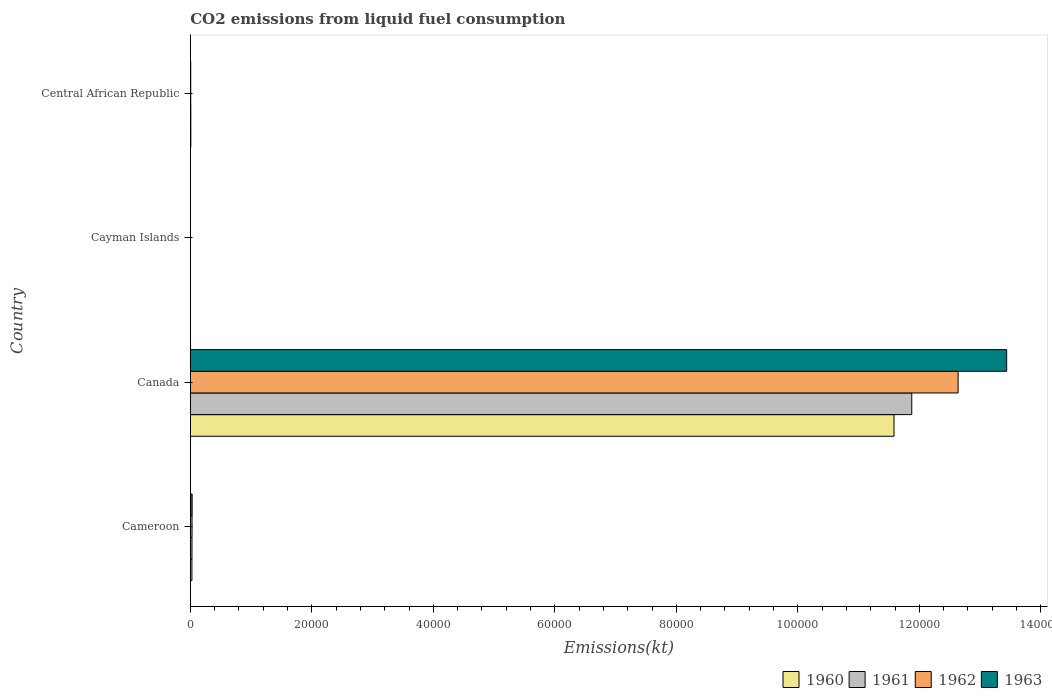How many groups of bars are there?
Your answer should be very brief. 4. Are the number of bars per tick equal to the number of legend labels?
Ensure brevity in your answer.  Yes. Are the number of bars on each tick of the Y-axis equal?
Ensure brevity in your answer.  Yes. How many bars are there on the 2nd tick from the top?
Provide a short and direct response. 4. How many bars are there on the 4th tick from the bottom?
Offer a very short reply. 4. What is the label of the 4th group of bars from the top?
Offer a very short reply. Cameroon. What is the amount of CO2 emitted in 1962 in Central African Republic?
Your answer should be very brief. 73.34. Across all countries, what is the maximum amount of CO2 emitted in 1962?
Ensure brevity in your answer.  1.26e+05. Across all countries, what is the minimum amount of CO2 emitted in 1960?
Provide a short and direct response. 11. In which country was the amount of CO2 emitted in 1961 maximum?
Make the answer very short. Canada. In which country was the amount of CO2 emitted in 1963 minimum?
Give a very brief answer. Cayman Islands. What is the total amount of CO2 emitted in 1960 in the graph?
Your answer should be very brief. 1.16e+05. What is the difference between the amount of CO2 emitted in 1962 in Cameroon and that in Canada?
Provide a succinct answer. -1.26e+05. What is the difference between the amount of CO2 emitted in 1960 in Cameroon and the amount of CO2 emitted in 1962 in Central African Republic?
Provide a succinct answer. 194.35. What is the average amount of CO2 emitted in 1962 per country?
Give a very brief answer. 3.17e+04. What is the difference between the amount of CO2 emitted in 1963 and amount of CO2 emitted in 1962 in Canada?
Keep it short and to the point. 7990.39. In how many countries, is the amount of CO2 emitted in 1962 greater than 64000 kt?
Your answer should be compact. 1. What is the ratio of the amount of CO2 emitted in 1962 in Canada to that in Cayman Islands?
Ensure brevity in your answer.  1.15e+04. Is the amount of CO2 emitted in 1961 in Cayman Islands less than that in Central African Republic?
Ensure brevity in your answer.  Yes. Is the difference between the amount of CO2 emitted in 1963 in Cameroon and Canada greater than the difference between the amount of CO2 emitted in 1962 in Cameroon and Canada?
Ensure brevity in your answer.  No. What is the difference between the highest and the second highest amount of CO2 emitted in 1960?
Provide a short and direct response. 1.16e+05. What is the difference between the highest and the lowest amount of CO2 emitted in 1960?
Your answer should be compact. 1.16e+05. Is the sum of the amount of CO2 emitted in 1962 in Canada and Central African Republic greater than the maximum amount of CO2 emitted in 1963 across all countries?
Your answer should be very brief. No. Is it the case that in every country, the sum of the amount of CO2 emitted in 1960 and amount of CO2 emitted in 1963 is greater than the sum of amount of CO2 emitted in 1962 and amount of CO2 emitted in 1961?
Your response must be concise. No. What does the 3rd bar from the top in Cameroon represents?
Your answer should be compact. 1961. Is it the case that in every country, the sum of the amount of CO2 emitted in 1960 and amount of CO2 emitted in 1963 is greater than the amount of CO2 emitted in 1961?
Offer a very short reply. Yes. Are all the bars in the graph horizontal?
Your answer should be compact. Yes. How many countries are there in the graph?
Provide a succinct answer. 4. What is the difference between two consecutive major ticks on the X-axis?
Offer a very short reply. 2.00e+04. Are the values on the major ticks of X-axis written in scientific E-notation?
Give a very brief answer. No. Does the graph contain grids?
Ensure brevity in your answer.  No. How many legend labels are there?
Your answer should be very brief. 4. What is the title of the graph?
Provide a short and direct response. CO2 emissions from liquid fuel consumption. What is the label or title of the X-axis?
Provide a short and direct response. Emissions(kt). What is the label or title of the Y-axis?
Offer a terse response. Country. What is the Emissions(kt) in 1960 in Cameroon?
Make the answer very short. 267.69. What is the Emissions(kt) of 1961 in Cameroon?
Keep it short and to the point. 278.69. What is the Emissions(kt) of 1962 in Cameroon?
Your answer should be very brief. 289.69. What is the Emissions(kt) in 1963 in Cameroon?
Your answer should be compact. 300.69. What is the Emissions(kt) of 1960 in Canada?
Make the answer very short. 1.16e+05. What is the Emissions(kt) of 1961 in Canada?
Keep it short and to the point. 1.19e+05. What is the Emissions(kt) of 1962 in Canada?
Offer a very short reply. 1.26e+05. What is the Emissions(kt) of 1963 in Canada?
Your response must be concise. 1.34e+05. What is the Emissions(kt) of 1960 in Cayman Islands?
Keep it short and to the point. 11. What is the Emissions(kt) in 1961 in Cayman Islands?
Your answer should be compact. 11. What is the Emissions(kt) in 1962 in Cayman Islands?
Make the answer very short. 11. What is the Emissions(kt) in 1963 in Cayman Islands?
Offer a very short reply. 11. What is the Emissions(kt) in 1960 in Central African Republic?
Ensure brevity in your answer.  88.01. What is the Emissions(kt) in 1961 in Central African Republic?
Keep it short and to the point. 88.01. What is the Emissions(kt) in 1962 in Central African Republic?
Make the answer very short. 73.34. What is the Emissions(kt) in 1963 in Central African Republic?
Offer a terse response. 73.34. Across all countries, what is the maximum Emissions(kt) in 1960?
Make the answer very short. 1.16e+05. Across all countries, what is the maximum Emissions(kt) of 1961?
Offer a terse response. 1.19e+05. Across all countries, what is the maximum Emissions(kt) of 1962?
Provide a succinct answer. 1.26e+05. Across all countries, what is the maximum Emissions(kt) of 1963?
Make the answer very short. 1.34e+05. Across all countries, what is the minimum Emissions(kt) of 1960?
Keep it short and to the point. 11. Across all countries, what is the minimum Emissions(kt) in 1961?
Give a very brief answer. 11. Across all countries, what is the minimum Emissions(kt) of 1962?
Your response must be concise. 11. Across all countries, what is the minimum Emissions(kt) of 1963?
Your answer should be very brief. 11. What is the total Emissions(kt) in 1960 in the graph?
Provide a short and direct response. 1.16e+05. What is the total Emissions(kt) of 1961 in the graph?
Offer a terse response. 1.19e+05. What is the total Emissions(kt) of 1962 in the graph?
Give a very brief answer. 1.27e+05. What is the total Emissions(kt) in 1963 in the graph?
Offer a very short reply. 1.35e+05. What is the difference between the Emissions(kt) of 1960 in Cameroon and that in Canada?
Ensure brevity in your answer.  -1.16e+05. What is the difference between the Emissions(kt) in 1961 in Cameroon and that in Canada?
Your response must be concise. -1.18e+05. What is the difference between the Emissions(kt) of 1962 in Cameroon and that in Canada?
Your answer should be very brief. -1.26e+05. What is the difference between the Emissions(kt) in 1963 in Cameroon and that in Canada?
Provide a short and direct response. -1.34e+05. What is the difference between the Emissions(kt) of 1960 in Cameroon and that in Cayman Islands?
Give a very brief answer. 256.69. What is the difference between the Emissions(kt) in 1961 in Cameroon and that in Cayman Islands?
Ensure brevity in your answer.  267.69. What is the difference between the Emissions(kt) in 1962 in Cameroon and that in Cayman Islands?
Your response must be concise. 278.69. What is the difference between the Emissions(kt) in 1963 in Cameroon and that in Cayman Islands?
Make the answer very short. 289.69. What is the difference between the Emissions(kt) of 1960 in Cameroon and that in Central African Republic?
Offer a very short reply. 179.68. What is the difference between the Emissions(kt) of 1961 in Cameroon and that in Central African Republic?
Offer a terse response. 190.68. What is the difference between the Emissions(kt) of 1962 in Cameroon and that in Central African Republic?
Your response must be concise. 216.35. What is the difference between the Emissions(kt) in 1963 in Cameroon and that in Central African Republic?
Keep it short and to the point. 227.35. What is the difference between the Emissions(kt) in 1960 in Canada and that in Cayman Islands?
Make the answer very short. 1.16e+05. What is the difference between the Emissions(kt) of 1961 in Canada and that in Cayman Islands?
Offer a very short reply. 1.19e+05. What is the difference between the Emissions(kt) in 1962 in Canada and that in Cayman Islands?
Ensure brevity in your answer.  1.26e+05. What is the difference between the Emissions(kt) in 1963 in Canada and that in Cayman Islands?
Keep it short and to the point. 1.34e+05. What is the difference between the Emissions(kt) of 1960 in Canada and that in Central African Republic?
Your response must be concise. 1.16e+05. What is the difference between the Emissions(kt) in 1961 in Canada and that in Central African Republic?
Your answer should be compact. 1.19e+05. What is the difference between the Emissions(kt) in 1962 in Canada and that in Central African Republic?
Your response must be concise. 1.26e+05. What is the difference between the Emissions(kt) of 1963 in Canada and that in Central African Republic?
Offer a terse response. 1.34e+05. What is the difference between the Emissions(kt) in 1960 in Cayman Islands and that in Central African Republic?
Your answer should be compact. -77.01. What is the difference between the Emissions(kt) of 1961 in Cayman Islands and that in Central African Republic?
Your response must be concise. -77.01. What is the difference between the Emissions(kt) in 1962 in Cayman Islands and that in Central African Republic?
Offer a terse response. -62.34. What is the difference between the Emissions(kt) in 1963 in Cayman Islands and that in Central African Republic?
Ensure brevity in your answer.  -62.34. What is the difference between the Emissions(kt) of 1960 in Cameroon and the Emissions(kt) of 1961 in Canada?
Your response must be concise. -1.18e+05. What is the difference between the Emissions(kt) in 1960 in Cameroon and the Emissions(kt) in 1962 in Canada?
Your response must be concise. -1.26e+05. What is the difference between the Emissions(kt) of 1960 in Cameroon and the Emissions(kt) of 1963 in Canada?
Your answer should be very brief. -1.34e+05. What is the difference between the Emissions(kt) of 1961 in Cameroon and the Emissions(kt) of 1962 in Canada?
Make the answer very short. -1.26e+05. What is the difference between the Emissions(kt) in 1961 in Cameroon and the Emissions(kt) in 1963 in Canada?
Offer a very short reply. -1.34e+05. What is the difference between the Emissions(kt) in 1962 in Cameroon and the Emissions(kt) in 1963 in Canada?
Offer a terse response. -1.34e+05. What is the difference between the Emissions(kt) in 1960 in Cameroon and the Emissions(kt) in 1961 in Cayman Islands?
Your answer should be very brief. 256.69. What is the difference between the Emissions(kt) in 1960 in Cameroon and the Emissions(kt) in 1962 in Cayman Islands?
Provide a short and direct response. 256.69. What is the difference between the Emissions(kt) of 1960 in Cameroon and the Emissions(kt) of 1963 in Cayman Islands?
Offer a very short reply. 256.69. What is the difference between the Emissions(kt) of 1961 in Cameroon and the Emissions(kt) of 1962 in Cayman Islands?
Ensure brevity in your answer.  267.69. What is the difference between the Emissions(kt) of 1961 in Cameroon and the Emissions(kt) of 1963 in Cayman Islands?
Keep it short and to the point. 267.69. What is the difference between the Emissions(kt) in 1962 in Cameroon and the Emissions(kt) in 1963 in Cayman Islands?
Make the answer very short. 278.69. What is the difference between the Emissions(kt) of 1960 in Cameroon and the Emissions(kt) of 1961 in Central African Republic?
Provide a succinct answer. 179.68. What is the difference between the Emissions(kt) of 1960 in Cameroon and the Emissions(kt) of 1962 in Central African Republic?
Your answer should be compact. 194.35. What is the difference between the Emissions(kt) of 1960 in Cameroon and the Emissions(kt) of 1963 in Central African Republic?
Provide a succinct answer. 194.35. What is the difference between the Emissions(kt) of 1961 in Cameroon and the Emissions(kt) of 1962 in Central African Republic?
Keep it short and to the point. 205.35. What is the difference between the Emissions(kt) of 1961 in Cameroon and the Emissions(kt) of 1963 in Central African Republic?
Make the answer very short. 205.35. What is the difference between the Emissions(kt) in 1962 in Cameroon and the Emissions(kt) in 1963 in Central African Republic?
Your response must be concise. 216.35. What is the difference between the Emissions(kt) of 1960 in Canada and the Emissions(kt) of 1961 in Cayman Islands?
Your response must be concise. 1.16e+05. What is the difference between the Emissions(kt) in 1960 in Canada and the Emissions(kt) in 1962 in Cayman Islands?
Provide a succinct answer. 1.16e+05. What is the difference between the Emissions(kt) of 1960 in Canada and the Emissions(kt) of 1963 in Cayman Islands?
Provide a short and direct response. 1.16e+05. What is the difference between the Emissions(kt) in 1961 in Canada and the Emissions(kt) in 1962 in Cayman Islands?
Provide a short and direct response. 1.19e+05. What is the difference between the Emissions(kt) in 1961 in Canada and the Emissions(kt) in 1963 in Cayman Islands?
Offer a very short reply. 1.19e+05. What is the difference between the Emissions(kt) in 1962 in Canada and the Emissions(kt) in 1963 in Cayman Islands?
Your answer should be very brief. 1.26e+05. What is the difference between the Emissions(kt) in 1960 in Canada and the Emissions(kt) in 1961 in Central African Republic?
Offer a very short reply. 1.16e+05. What is the difference between the Emissions(kt) of 1960 in Canada and the Emissions(kt) of 1962 in Central African Republic?
Give a very brief answer. 1.16e+05. What is the difference between the Emissions(kt) in 1960 in Canada and the Emissions(kt) in 1963 in Central African Republic?
Make the answer very short. 1.16e+05. What is the difference between the Emissions(kt) of 1961 in Canada and the Emissions(kt) of 1962 in Central African Republic?
Offer a very short reply. 1.19e+05. What is the difference between the Emissions(kt) of 1961 in Canada and the Emissions(kt) of 1963 in Central African Republic?
Provide a succinct answer. 1.19e+05. What is the difference between the Emissions(kt) in 1962 in Canada and the Emissions(kt) in 1963 in Central African Republic?
Ensure brevity in your answer.  1.26e+05. What is the difference between the Emissions(kt) in 1960 in Cayman Islands and the Emissions(kt) in 1961 in Central African Republic?
Ensure brevity in your answer.  -77.01. What is the difference between the Emissions(kt) of 1960 in Cayman Islands and the Emissions(kt) of 1962 in Central African Republic?
Your answer should be very brief. -62.34. What is the difference between the Emissions(kt) of 1960 in Cayman Islands and the Emissions(kt) of 1963 in Central African Republic?
Make the answer very short. -62.34. What is the difference between the Emissions(kt) in 1961 in Cayman Islands and the Emissions(kt) in 1962 in Central African Republic?
Ensure brevity in your answer.  -62.34. What is the difference between the Emissions(kt) of 1961 in Cayman Islands and the Emissions(kt) of 1963 in Central African Republic?
Offer a very short reply. -62.34. What is the difference between the Emissions(kt) of 1962 in Cayman Islands and the Emissions(kt) of 1963 in Central African Republic?
Offer a terse response. -62.34. What is the average Emissions(kt) in 1960 per country?
Offer a terse response. 2.91e+04. What is the average Emissions(kt) of 1961 per country?
Offer a terse response. 2.98e+04. What is the average Emissions(kt) in 1962 per country?
Ensure brevity in your answer.  3.17e+04. What is the average Emissions(kt) of 1963 per country?
Make the answer very short. 3.37e+04. What is the difference between the Emissions(kt) of 1960 and Emissions(kt) of 1961 in Cameroon?
Provide a succinct answer. -11. What is the difference between the Emissions(kt) of 1960 and Emissions(kt) of 1962 in Cameroon?
Provide a succinct answer. -22. What is the difference between the Emissions(kt) of 1960 and Emissions(kt) of 1963 in Cameroon?
Offer a very short reply. -33. What is the difference between the Emissions(kt) of 1961 and Emissions(kt) of 1962 in Cameroon?
Provide a succinct answer. -11. What is the difference between the Emissions(kt) of 1961 and Emissions(kt) of 1963 in Cameroon?
Your answer should be compact. -22. What is the difference between the Emissions(kt) in 1962 and Emissions(kt) in 1963 in Cameroon?
Offer a terse response. -11. What is the difference between the Emissions(kt) of 1960 and Emissions(kt) of 1961 in Canada?
Your answer should be compact. -2922.6. What is the difference between the Emissions(kt) of 1960 and Emissions(kt) of 1962 in Canada?
Make the answer very short. -1.06e+04. What is the difference between the Emissions(kt) of 1960 and Emissions(kt) of 1963 in Canada?
Ensure brevity in your answer.  -1.85e+04. What is the difference between the Emissions(kt) of 1961 and Emissions(kt) of 1962 in Canada?
Provide a succinct answer. -7631.03. What is the difference between the Emissions(kt) in 1961 and Emissions(kt) in 1963 in Canada?
Give a very brief answer. -1.56e+04. What is the difference between the Emissions(kt) in 1962 and Emissions(kt) in 1963 in Canada?
Ensure brevity in your answer.  -7990.39. What is the difference between the Emissions(kt) in 1961 and Emissions(kt) in 1963 in Cayman Islands?
Give a very brief answer. 0. What is the difference between the Emissions(kt) in 1962 and Emissions(kt) in 1963 in Cayman Islands?
Give a very brief answer. 0. What is the difference between the Emissions(kt) of 1960 and Emissions(kt) of 1962 in Central African Republic?
Provide a short and direct response. 14.67. What is the difference between the Emissions(kt) of 1960 and Emissions(kt) of 1963 in Central African Republic?
Ensure brevity in your answer.  14.67. What is the difference between the Emissions(kt) in 1961 and Emissions(kt) in 1962 in Central African Republic?
Give a very brief answer. 14.67. What is the difference between the Emissions(kt) in 1961 and Emissions(kt) in 1963 in Central African Republic?
Your answer should be compact. 14.67. What is the difference between the Emissions(kt) of 1962 and Emissions(kt) of 1963 in Central African Republic?
Offer a terse response. 0. What is the ratio of the Emissions(kt) of 1960 in Cameroon to that in Canada?
Offer a very short reply. 0. What is the ratio of the Emissions(kt) of 1961 in Cameroon to that in Canada?
Your answer should be very brief. 0. What is the ratio of the Emissions(kt) in 1962 in Cameroon to that in Canada?
Ensure brevity in your answer.  0. What is the ratio of the Emissions(kt) in 1963 in Cameroon to that in Canada?
Provide a short and direct response. 0. What is the ratio of the Emissions(kt) of 1960 in Cameroon to that in Cayman Islands?
Give a very brief answer. 24.33. What is the ratio of the Emissions(kt) in 1961 in Cameroon to that in Cayman Islands?
Ensure brevity in your answer.  25.33. What is the ratio of the Emissions(kt) in 1962 in Cameroon to that in Cayman Islands?
Your answer should be very brief. 26.33. What is the ratio of the Emissions(kt) of 1963 in Cameroon to that in Cayman Islands?
Provide a succinct answer. 27.33. What is the ratio of the Emissions(kt) in 1960 in Cameroon to that in Central African Republic?
Provide a short and direct response. 3.04. What is the ratio of the Emissions(kt) in 1961 in Cameroon to that in Central African Republic?
Offer a terse response. 3.17. What is the ratio of the Emissions(kt) of 1962 in Cameroon to that in Central African Republic?
Provide a succinct answer. 3.95. What is the ratio of the Emissions(kt) of 1963 in Cameroon to that in Central African Republic?
Your answer should be compact. 4.1. What is the ratio of the Emissions(kt) of 1960 in Canada to that in Cayman Islands?
Keep it short and to the point. 1.05e+04. What is the ratio of the Emissions(kt) of 1961 in Canada to that in Cayman Islands?
Provide a short and direct response. 1.08e+04. What is the ratio of the Emissions(kt) in 1962 in Canada to that in Cayman Islands?
Provide a short and direct response. 1.15e+04. What is the ratio of the Emissions(kt) of 1963 in Canada to that in Cayman Islands?
Provide a short and direct response. 1.22e+04. What is the ratio of the Emissions(kt) in 1960 in Canada to that in Central African Republic?
Your answer should be very brief. 1316.21. What is the ratio of the Emissions(kt) of 1961 in Canada to that in Central African Republic?
Your answer should be compact. 1349.42. What is the ratio of the Emissions(kt) in 1962 in Canada to that in Central African Republic?
Offer a very short reply. 1723.35. What is the ratio of the Emissions(kt) of 1963 in Canada to that in Central African Republic?
Provide a succinct answer. 1832.3. What is the ratio of the Emissions(kt) of 1962 in Cayman Islands to that in Central African Republic?
Provide a succinct answer. 0.15. What is the ratio of the Emissions(kt) of 1963 in Cayman Islands to that in Central African Republic?
Provide a short and direct response. 0.15. What is the difference between the highest and the second highest Emissions(kt) of 1960?
Provide a succinct answer. 1.16e+05. What is the difference between the highest and the second highest Emissions(kt) of 1961?
Keep it short and to the point. 1.18e+05. What is the difference between the highest and the second highest Emissions(kt) in 1962?
Make the answer very short. 1.26e+05. What is the difference between the highest and the second highest Emissions(kt) of 1963?
Give a very brief answer. 1.34e+05. What is the difference between the highest and the lowest Emissions(kt) in 1960?
Offer a terse response. 1.16e+05. What is the difference between the highest and the lowest Emissions(kt) in 1961?
Offer a terse response. 1.19e+05. What is the difference between the highest and the lowest Emissions(kt) in 1962?
Ensure brevity in your answer.  1.26e+05. What is the difference between the highest and the lowest Emissions(kt) of 1963?
Make the answer very short. 1.34e+05. 